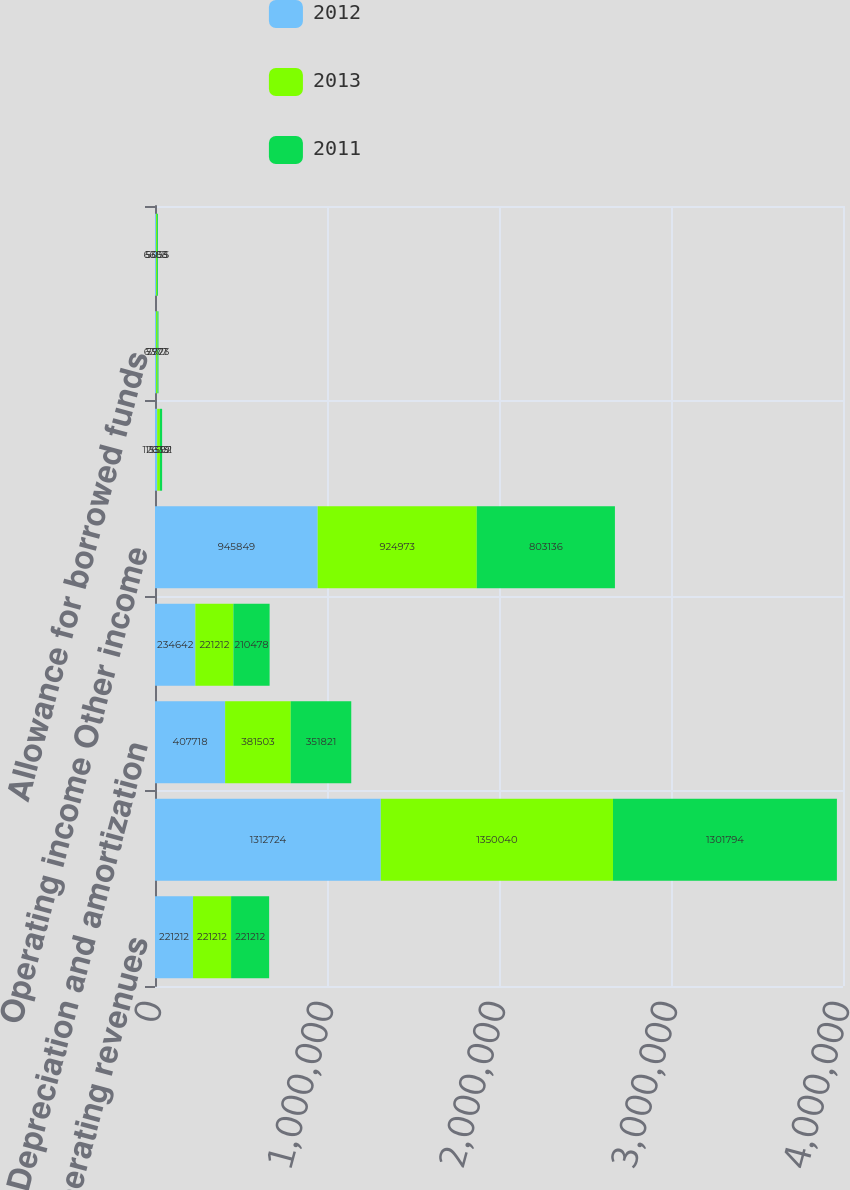Convert chart. <chart><loc_0><loc_0><loc_500><loc_500><stacked_bar_chart><ecel><fcel>Operating revenues<fcel>Operation and maintenance<fcel>Depreciation and amortization<fcel>General taxes (Gain) loss on<fcel>Operating income Other income<fcel>Loss on extinguishment of debt<fcel>Allowance for borrowed funds<fcel>Amortization of debt expense<nl><fcel>2012<fcel>221212<fcel>1.31272e+06<fcel>407718<fcel>234642<fcel>945849<fcel>12639<fcel>6377<fcel>6603<nl><fcel>2013<fcel>221212<fcel>1.35004e+06<fcel>381503<fcel>221212<fcel>924973<fcel>15592<fcel>7771<fcel>5358<nl><fcel>2011<fcel>221212<fcel>1.30179e+06<fcel>351821<fcel>210478<fcel>803136<fcel>13131<fcel>5923<fcel>5055<nl></chart> 